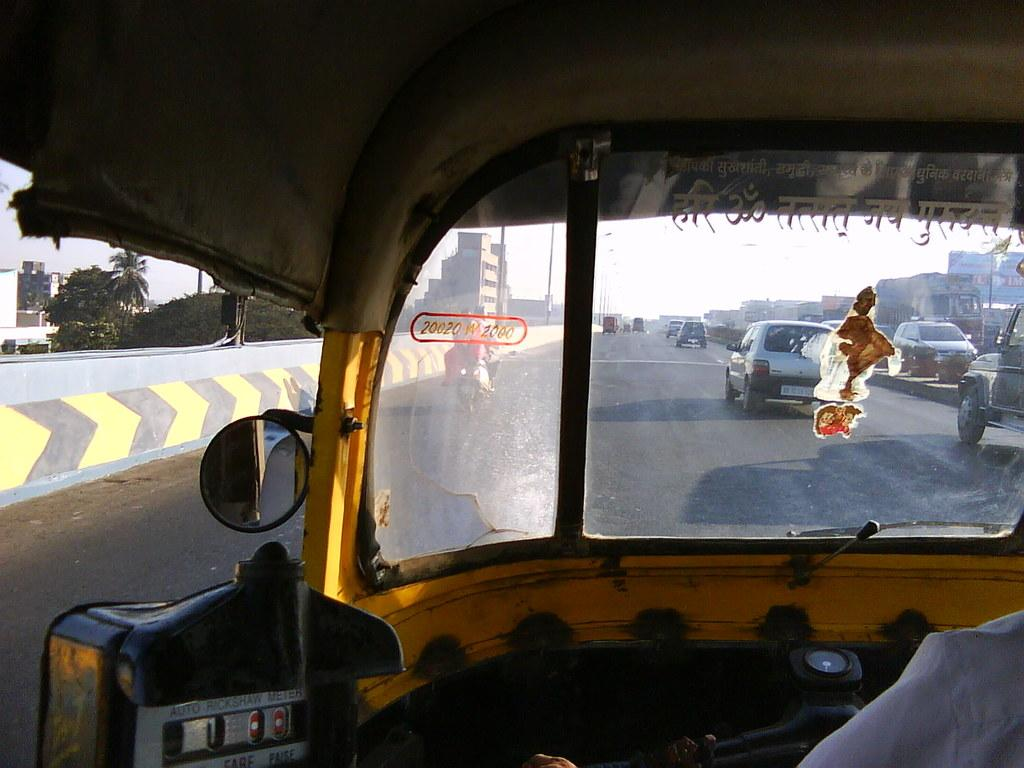What is the main subject of the image? The main subject of the image is a road. What mode of transportation is being used to capture the image? The image is taken from an auto rickshaw. What is happening on the road in the image? Cars are moving on the road in the image. What can be seen in the background of the image? There are trees, buildings, and the sky visible in the background of the image. What type of silk is being used to make the lake in the image? There is no silk or lake present in the image; it features a road with cars moving and a background with trees, buildings, and the sky. 